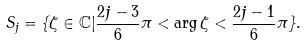<formula> <loc_0><loc_0><loc_500><loc_500>S _ { j } = \{ \zeta \in \mathbb { C } | \frac { 2 j - 3 } { 6 } \pi < \arg \zeta < \frac { 2 j - 1 } { 6 } \pi \} .</formula> 